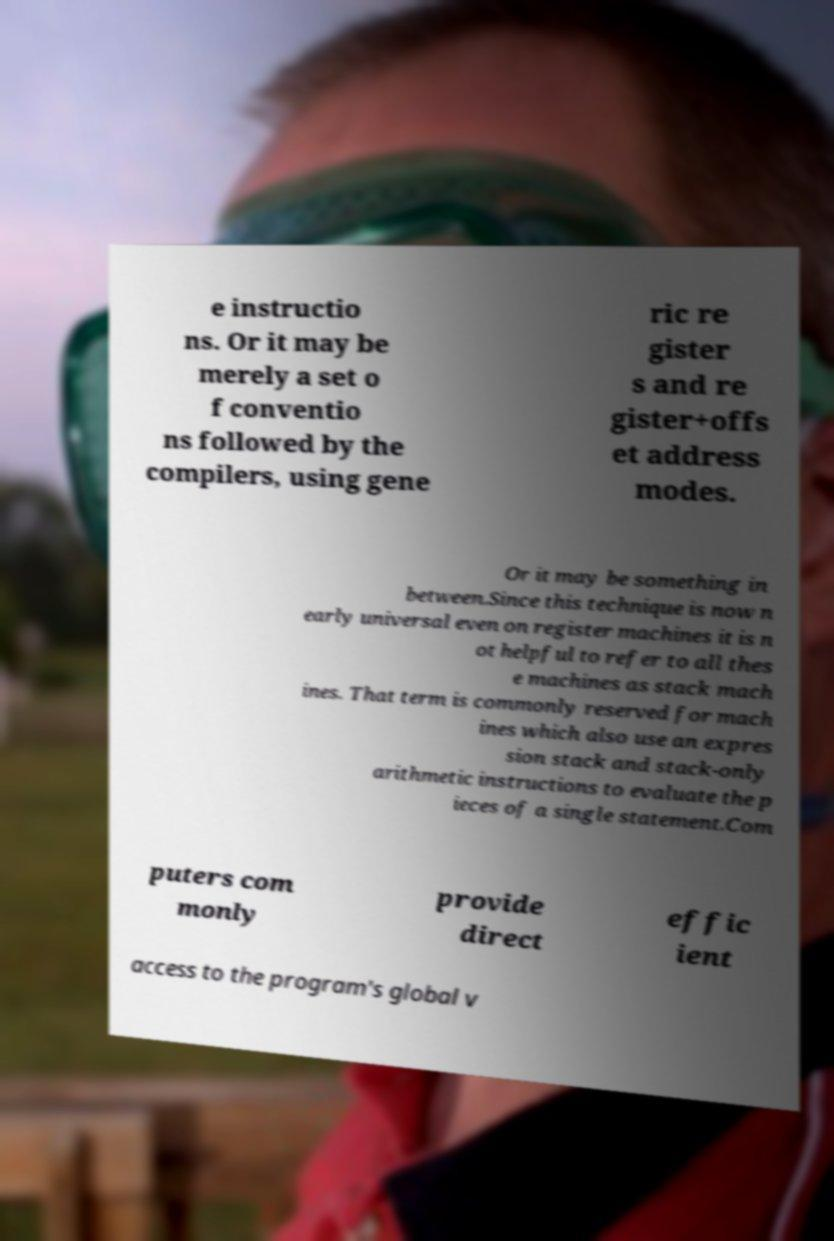Can you read and provide the text displayed in the image?This photo seems to have some interesting text. Can you extract and type it out for me? e instructio ns. Or it may be merely a set o f conventio ns followed by the compilers, using gene ric re gister s and re gister+offs et address modes. Or it may be something in between.Since this technique is now n early universal even on register machines it is n ot helpful to refer to all thes e machines as stack mach ines. That term is commonly reserved for mach ines which also use an expres sion stack and stack-only arithmetic instructions to evaluate the p ieces of a single statement.Com puters com monly provide direct effic ient access to the program's global v 